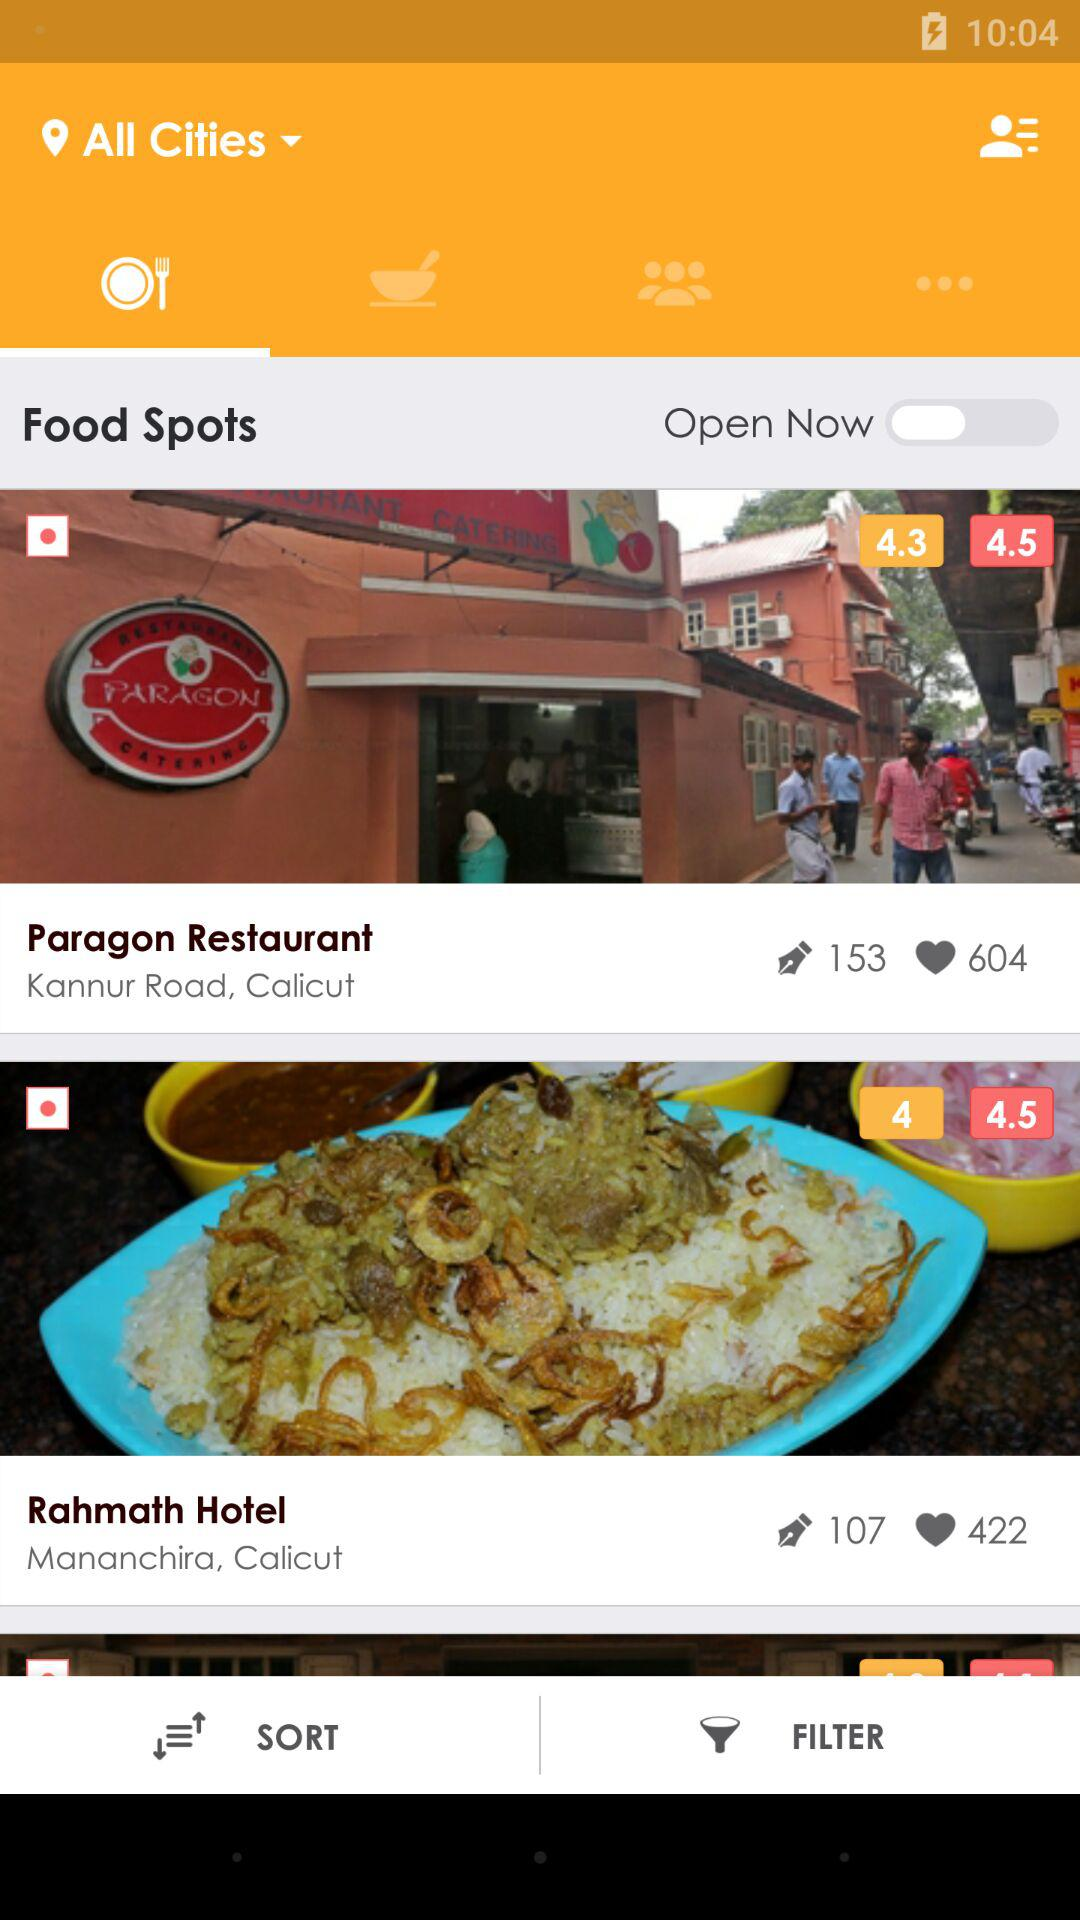How many restaurants are there in total?
Answer the question using a single word or phrase. 2 